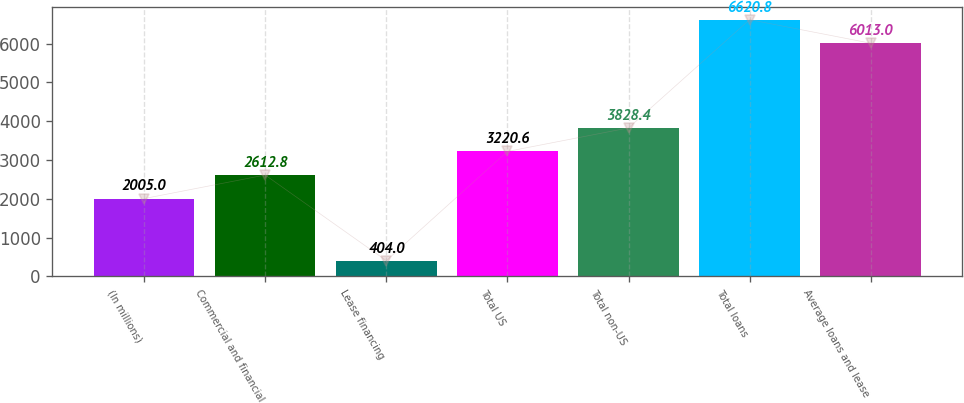Convert chart. <chart><loc_0><loc_0><loc_500><loc_500><bar_chart><fcel>(In millions)<fcel>Commercial and financial<fcel>Lease financing<fcel>Total US<fcel>Total non-US<fcel>Total loans<fcel>Average loans and lease<nl><fcel>2005<fcel>2612.8<fcel>404<fcel>3220.6<fcel>3828.4<fcel>6620.8<fcel>6013<nl></chart> 